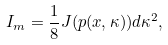Convert formula to latex. <formula><loc_0><loc_0><loc_500><loc_500>I _ { m } = \frac { 1 } { 8 } J ( p ( x , \kappa ) ) d \kappa ^ { 2 } ,</formula> 